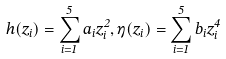Convert formula to latex. <formula><loc_0><loc_0><loc_500><loc_500>h ( z _ { i } ) = \sum _ { i = 1 } ^ { 5 } a _ { i } z _ { i } ^ { 2 } , \eta ( z _ { i } ) = \sum _ { i = 1 } ^ { 5 } b _ { i } z _ { i } ^ { 4 }</formula> 